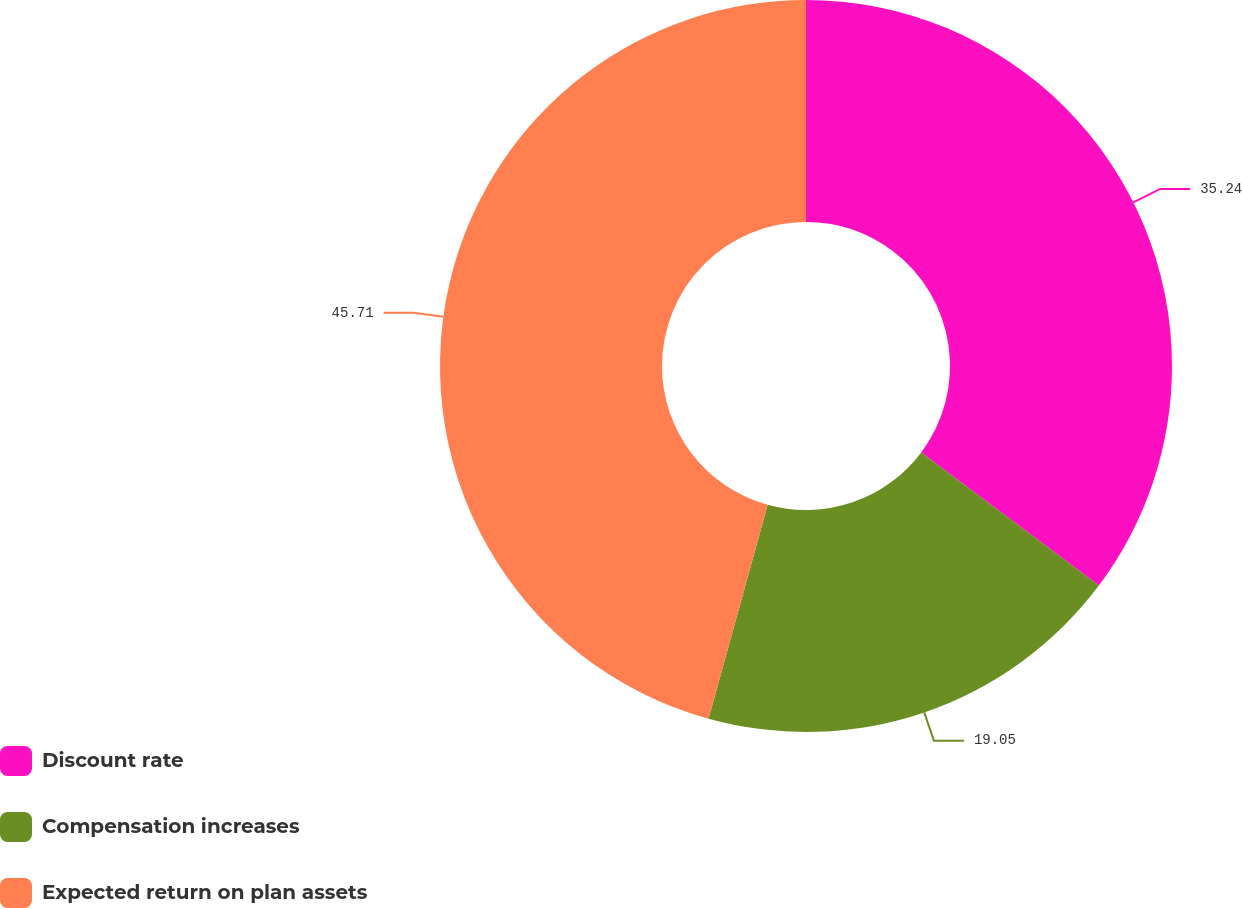Convert chart to OTSL. <chart><loc_0><loc_0><loc_500><loc_500><pie_chart><fcel>Discount rate<fcel>Compensation increases<fcel>Expected return on plan assets<nl><fcel>35.24%<fcel>19.05%<fcel>45.71%<nl></chart> 